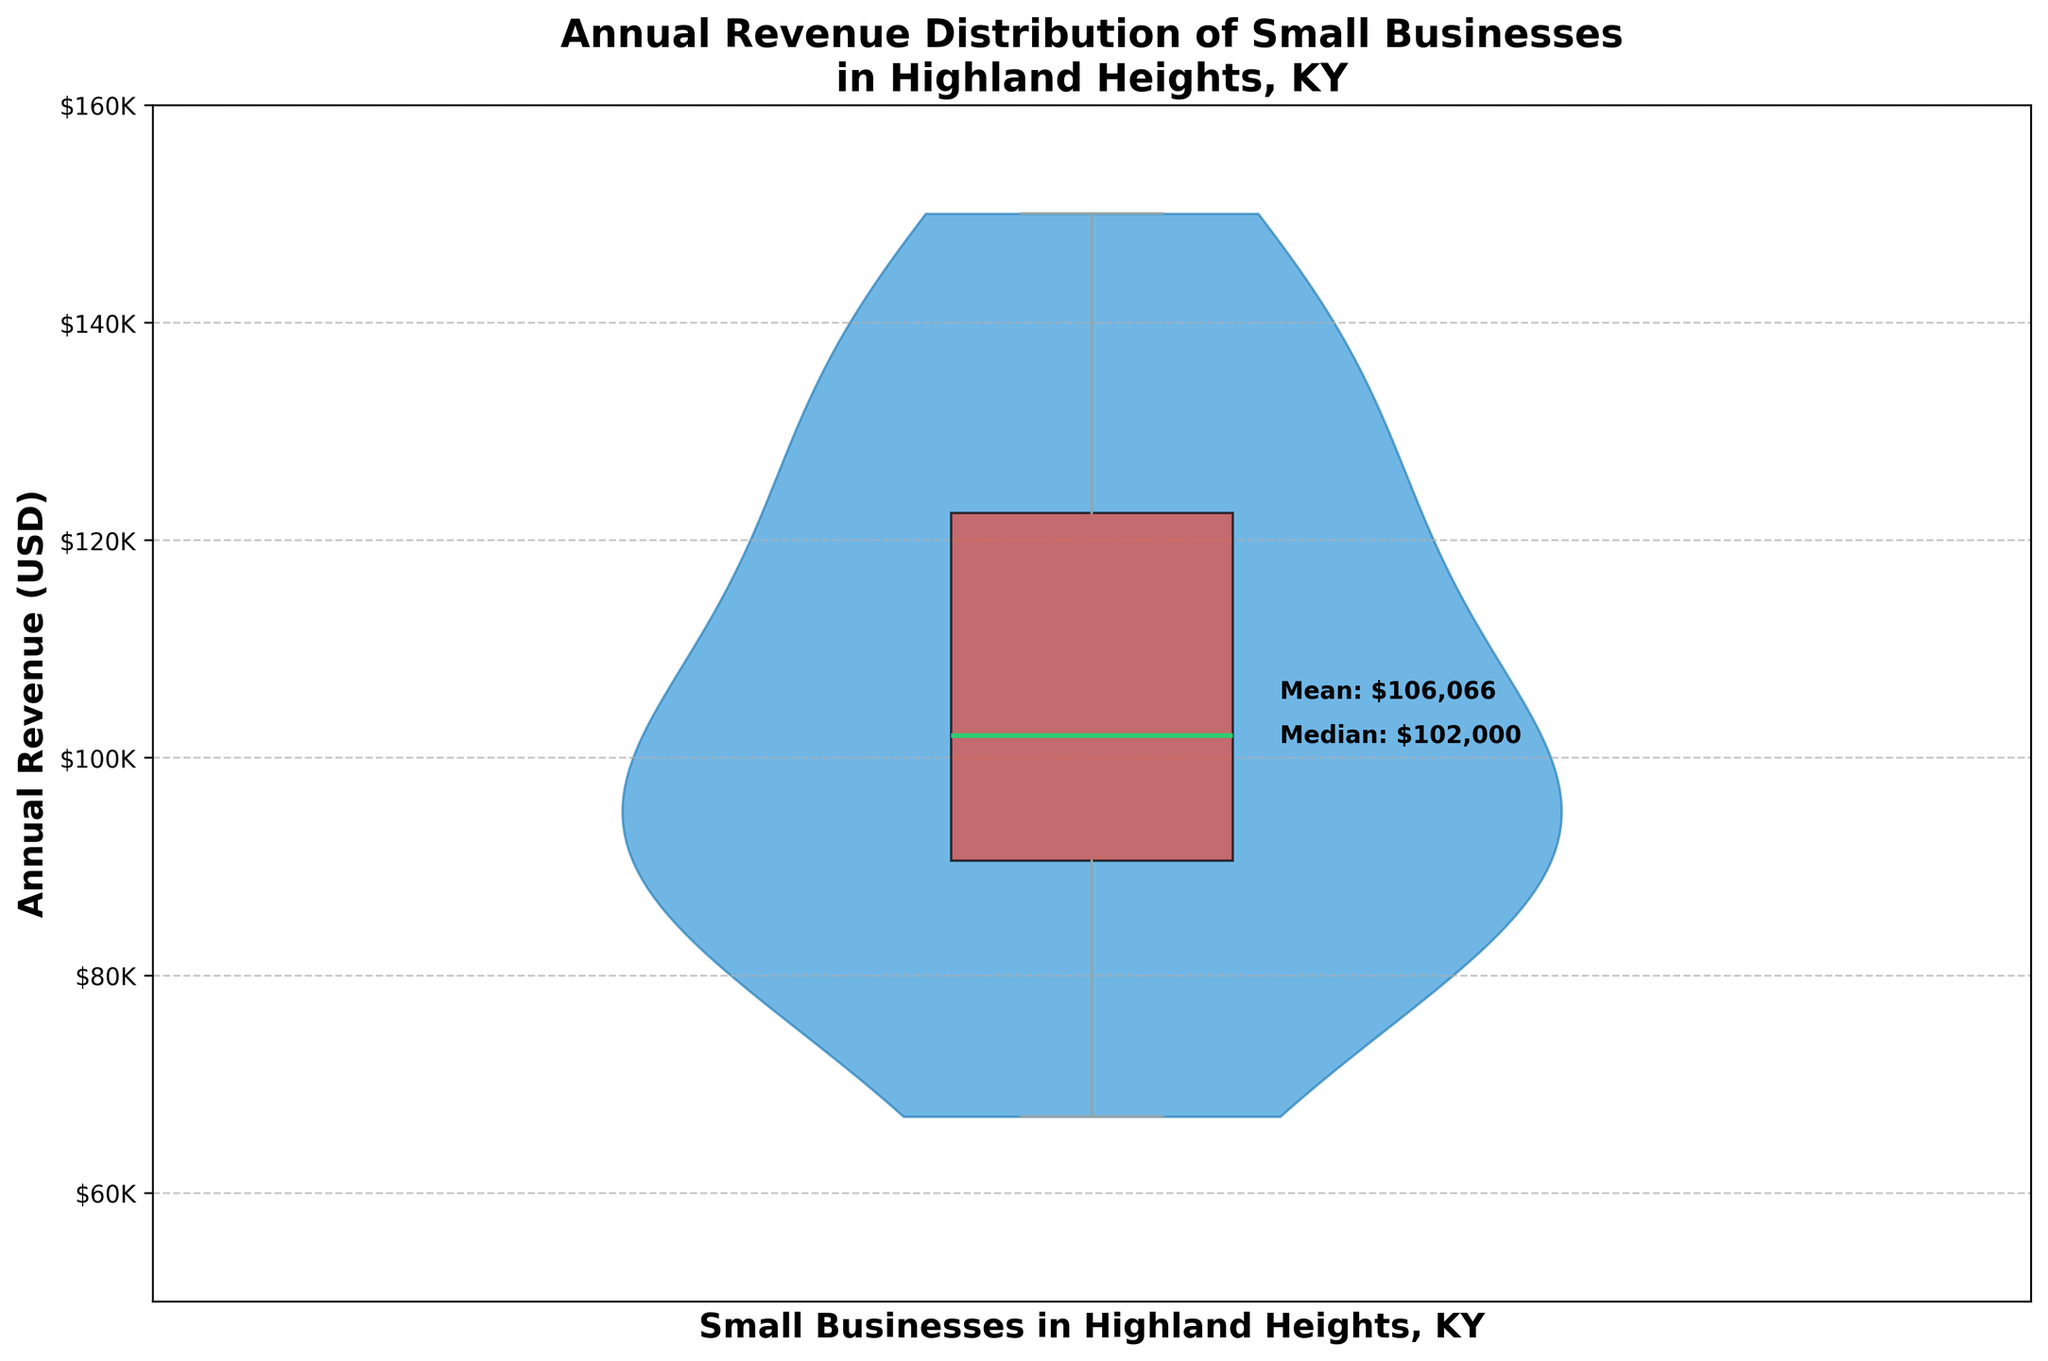What is the title of the chart? The title of the chart is typically found at the top and describes the contents of the visual representation in the figure.
Answer: Annual Revenue Distribution of Small Businesses in Highland Heights, KY What is the median annual revenue of the small businesses? The median is shown with an annotation on the chart. It can be found by locating the label "Median" on the figure.
Answer: $102,000 What is the mean annual revenue of the small businesses? The mean is annotated on the chart. It can be identified by looking at the label "Mean" on the figure.
Answer: $104,067 Which small business in Highland Heights, Ky., has the highest annual revenue? The highest point in the data is shown as part of the violin plot extending to the maximum value. The chart itself, however, may not name businesses individually (requires context from provided data). According to the data, this is Tech Solutions IT.
Answer: Tech Solutions IT What is the range of annual revenues for the small businesses? The range is calculated by subtracting the minimum revenue from the maximum revenue. The visual range can be inferred from the violin plot (maximum $150,000 - minimum $67,000).
Answer: $83,000 How many small businesses are being analyzed in the chart? To find this, one can either count the number of individual data points or refer to the provided data table.
Answer: 15 Which color represents the body of the violin in the chart? The body of the violin plot is shown in a specific color that can be described visually.
Answer: Light blue What is the color of the box plot? The box plot is depicted in a different color which can be identified from the chart.
Answer: Light red What is depicted by the green line within the box plot? The green line in the box plot represents a specific statistical measure, which is provided as part of the box plot overlay information.
Answer: Median Given the data on the chart, which business might be considered the median business in terms of revenue? The median business can be thought of as the one whose revenue is in the middle of the sorted dataset; the chart shows the median revenue. According to the data, this would correspond approximately to Sunset Yoga Studio.
Answer: Sunset Yoga Studio 